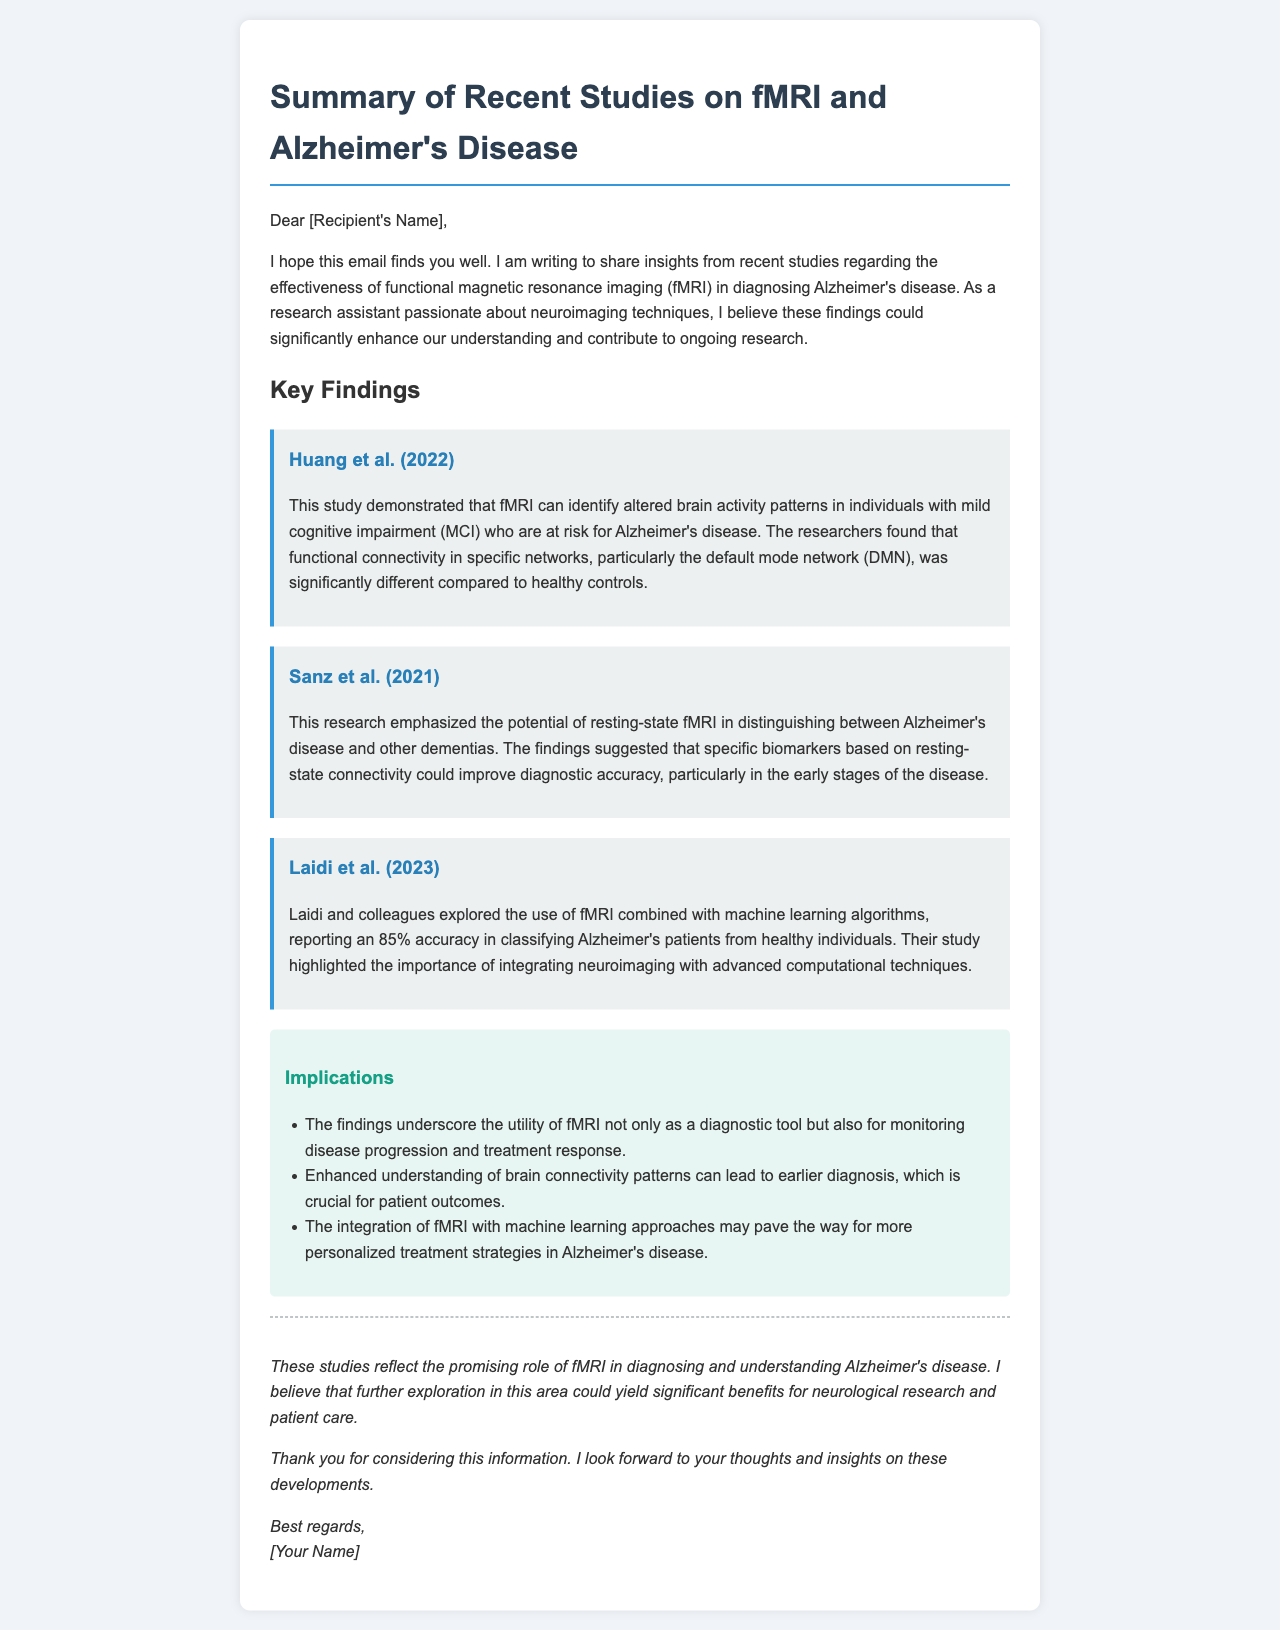What is the title of the email? The title is "Summary of Recent Studies on fMRI and Alzheimer's Disease," as stated in the heading of the email.
Answer: Summary of Recent Studies on fMRI and Alzheimer's Disease Who conducted the study that identified altered brain activity patterns in MCI? The study was conducted by Huang et al. in 2022, as mentioned in the key findings section.
Answer: Huang et al. (2022) What significant accuracy was reported by Laidi et al. (2023) in classifying Alzheimer's patients? Laidi et al. reported an accuracy of 85%, which is specified in their study overview.
Answer: 85% Which network was significantly different in individuals with mild cognitive impairment according to Huang et al. (2022)? The default mode network (DMN) was identified as significantly different in the study.
Answer: default mode network (DMN) What type of fMRI is emphasized by Sanz et al. (2021) for distinguishing Alzheimer's disease? Sanz et al. emphasized resting-state fMRI as a key tool in their research.
Answer: resting-state fMRI What implication relates to monitoring in Alzheimer's disease? The findings suggest that fMRI can be used not only for diagnosis but also for monitoring disease progression and treatment response.
Answer: monitoring disease progression and treatment response What advanced technique did Laidi et al. combine with fMRI in their study? Laidi et al. combined machine learning algorithms with fMRI to improve classification accuracy.
Answer: machine learning algorithms What year was the study by Sanz et al. published? The study by Sanz et al. was published in 2021, as indicated in the document.
Answer: 2021 